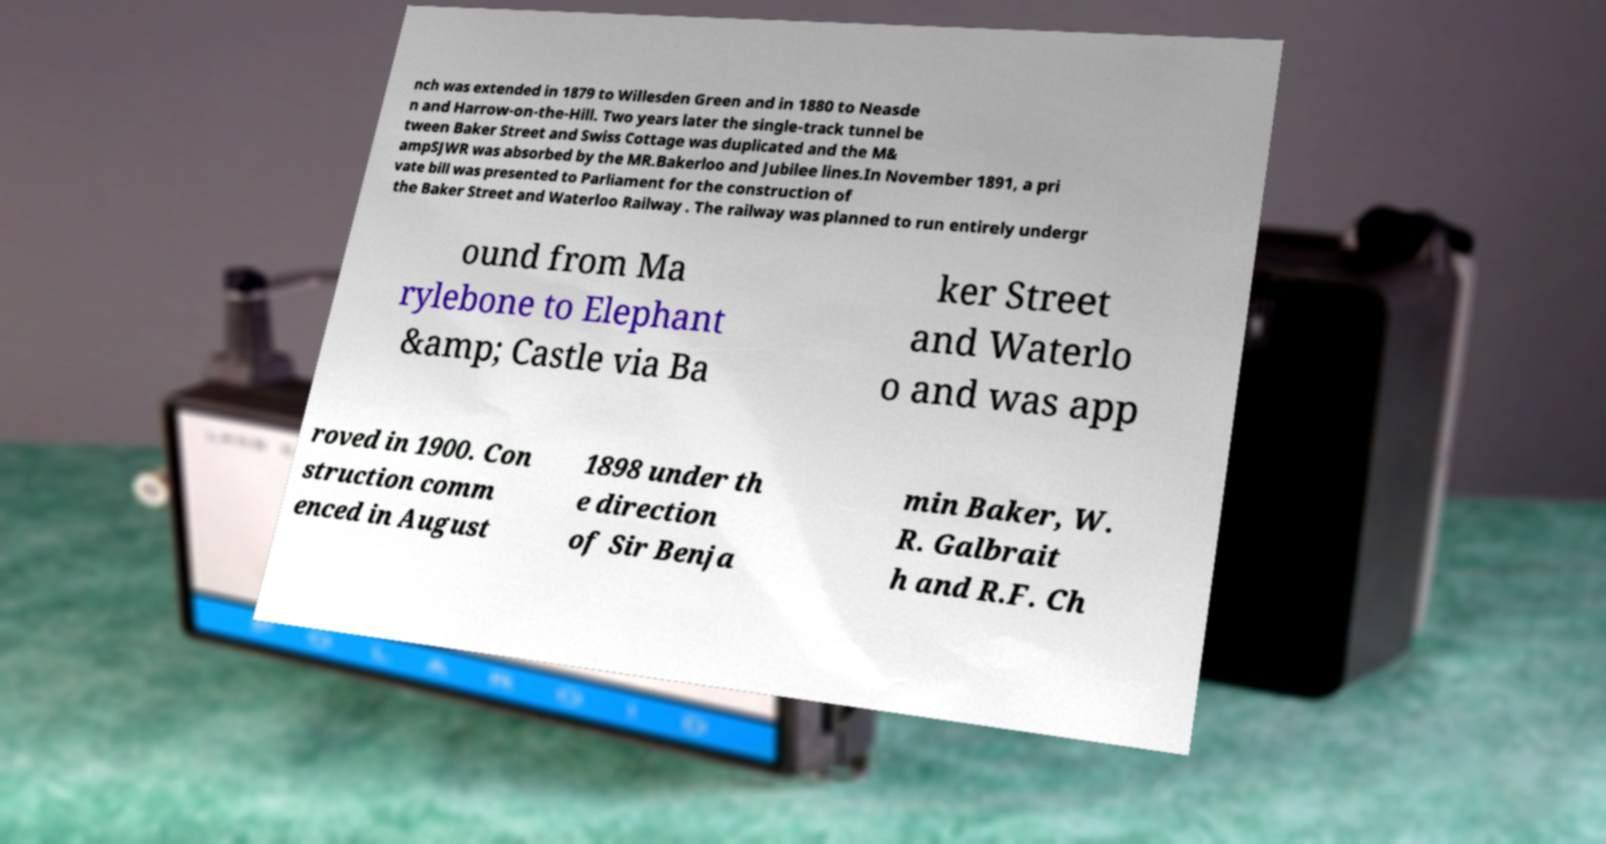Can you accurately transcribe the text from the provided image for me? nch was extended in 1879 to Willesden Green and in 1880 to Neasde n and Harrow-on-the-Hill. Two years later the single-track tunnel be tween Baker Street and Swiss Cottage was duplicated and the M& ampSJWR was absorbed by the MR.Bakerloo and Jubilee lines.In November 1891, a pri vate bill was presented to Parliament for the construction of the Baker Street and Waterloo Railway . The railway was planned to run entirely undergr ound from Ma rylebone to Elephant &amp; Castle via Ba ker Street and Waterlo o and was app roved in 1900. Con struction comm enced in August 1898 under th e direction of Sir Benja min Baker, W. R. Galbrait h and R.F. Ch 